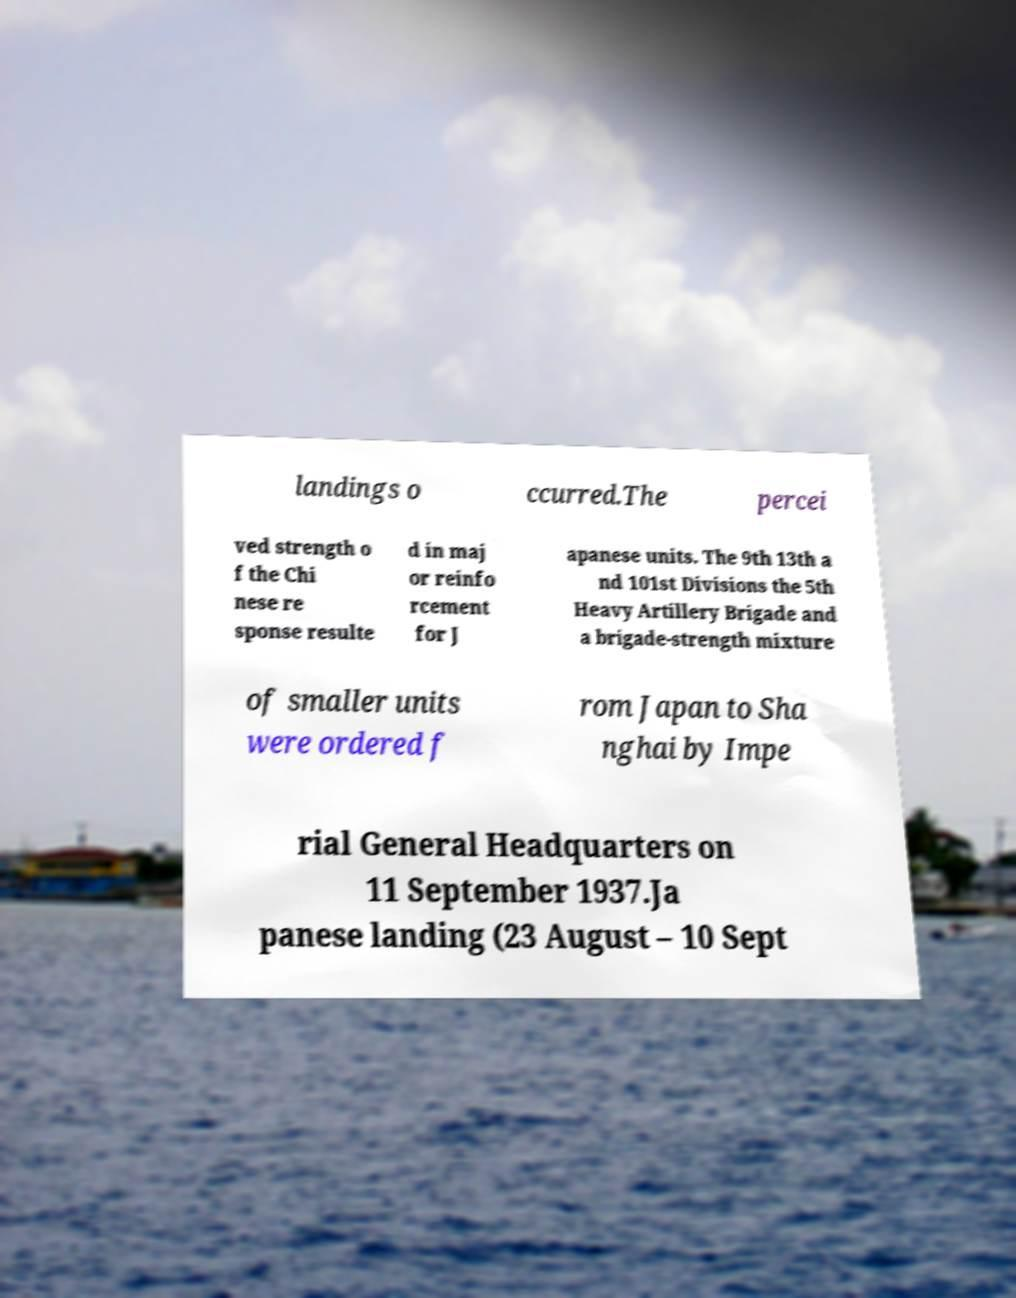I need the written content from this picture converted into text. Can you do that? landings o ccurred.The percei ved strength o f the Chi nese re sponse resulte d in maj or reinfo rcement for J apanese units. The 9th 13th a nd 101st Divisions the 5th Heavy Artillery Brigade and a brigade-strength mixture of smaller units were ordered f rom Japan to Sha nghai by Impe rial General Headquarters on 11 September 1937.Ja panese landing (23 August – 10 Sept 